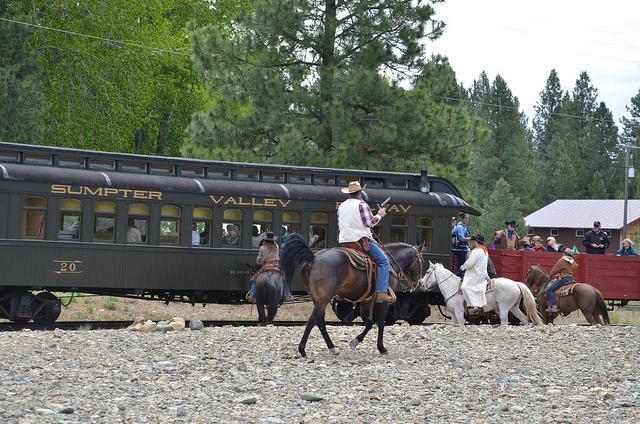How many horses are there?
Give a very brief answer. 3. 